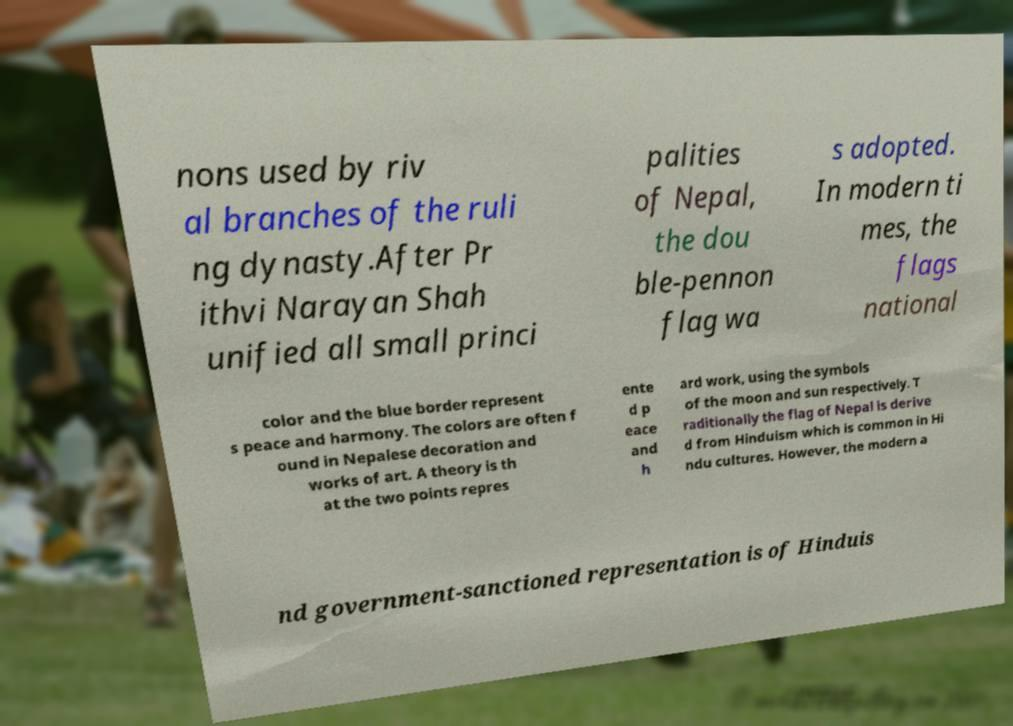I need the written content from this picture converted into text. Can you do that? nons used by riv al branches of the ruli ng dynasty.After Pr ithvi Narayan Shah unified all small princi palities of Nepal, the dou ble-pennon flag wa s adopted. In modern ti mes, the flags national color and the blue border represent s peace and harmony. The colors are often f ound in Nepalese decoration and works of art. A theory is th at the two points repres ente d p eace and h ard work, using the symbols of the moon and sun respectively. T raditionally the flag of Nepal is derive d from Hinduism which is common in Hi ndu cultures. However, the modern a nd government-sanctioned representation is of Hinduis 